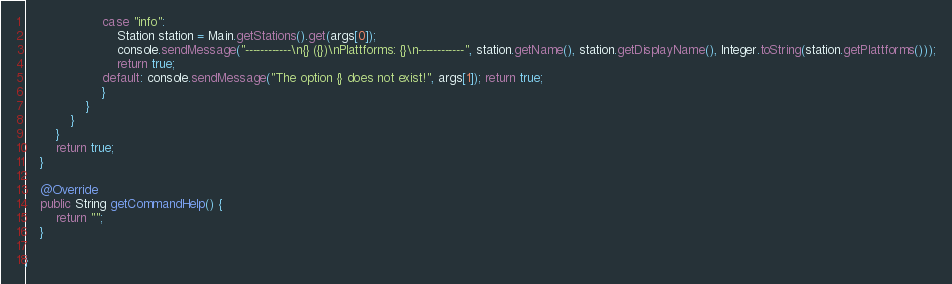Convert code to text. <code><loc_0><loc_0><loc_500><loc_500><_Java_>					case "info": 
						Station station = Main.getStations().get(args[0]);
						console.sendMessage("------------\n{} ({})\nPlattforms: {}\n------------", station.getName(), station.getDisplayName(), Integer.toString(station.getPlattforms()));
						return true;
					default: console.sendMessage("The option {} does not exist!", args[1]); return true;
					}
				}
			}
		}
		return true;
	}
	
	@Override
	public String getCommandHelp() {
		return "";
	}

}
</code> 